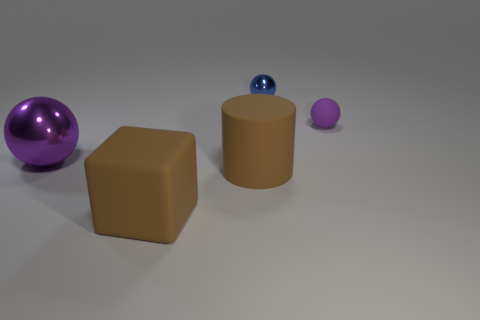What is the shape of the blue metallic thing that is the same size as the rubber sphere?
Make the answer very short. Sphere. How many big matte cubes are the same color as the matte cylinder?
Offer a terse response. 1. Are there fewer large brown rubber cubes behind the tiny shiny sphere than shiny spheres that are on the right side of the big metal thing?
Give a very brief answer. Yes. There is a big metallic thing; are there any big objects in front of it?
Ensure brevity in your answer.  Yes. There is a big object that is in front of the large matte cylinder that is right of the big shiny thing; is there a sphere that is in front of it?
Provide a short and direct response. No. Is the shape of the matte thing that is in front of the big brown cylinder the same as  the blue metal object?
Your answer should be very brief. No. There is a ball that is made of the same material as the brown cube; what color is it?
Offer a very short reply. Purple. What number of objects are made of the same material as the big cylinder?
Make the answer very short. 2. There is a shiny object that is to the right of the large brown matte thing right of the big brown rubber object in front of the big cylinder; what color is it?
Your response must be concise. Blue. Do the blue metallic sphere and the rubber cylinder have the same size?
Your answer should be compact. No. 